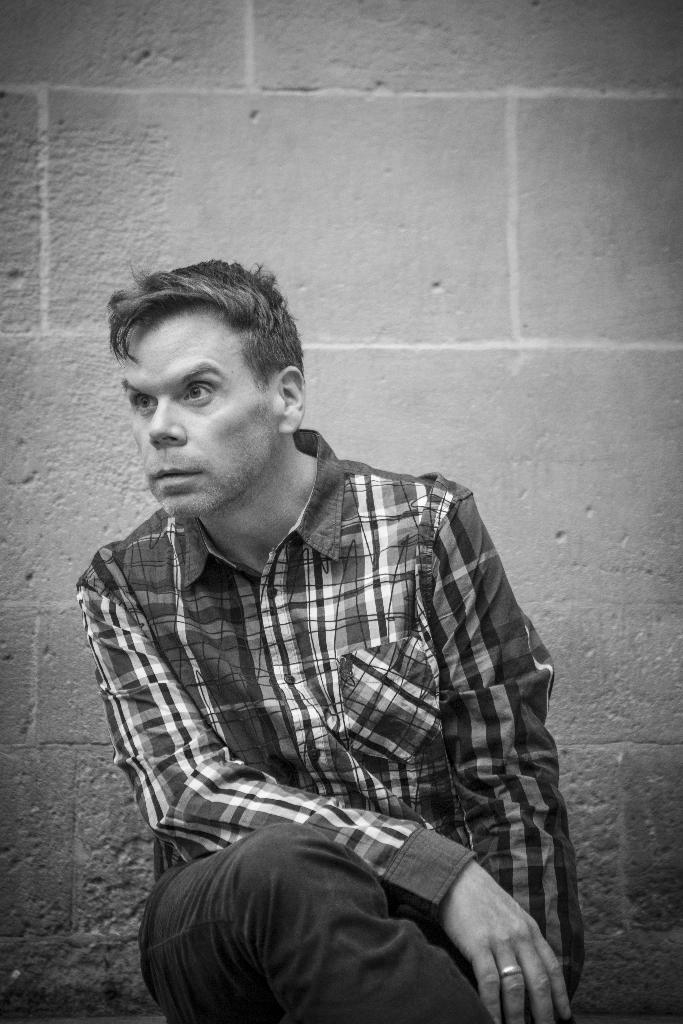What is the main subject of the image? There is a man sitting in the image. What can be seen in the background of the image? There is a wall in the background of the image. What is the color scheme of the image? The image is black and white. What letters are visible on the sun in the image? There is no sun or letters present in the image; it is a black and white image of a man sitting in front of a wall. 